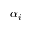Convert formula to latex. <formula><loc_0><loc_0><loc_500><loc_500>\alpha _ { i }</formula> 